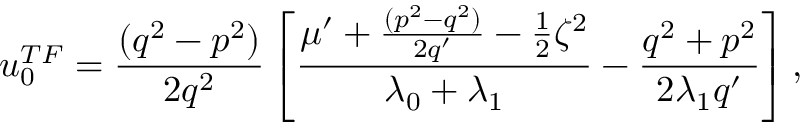Convert formula to latex. <formula><loc_0><loc_0><loc_500><loc_500>u _ { 0 } ^ { T F } = \frac { ( q ^ { 2 } - p ^ { 2 } ) } { 2 q ^ { 2 } } \left [ \frac { \mu ^ { \prime } + \frac { ( p ^ { 2 } - q ^ { 2 } ) } { 2 q ^ { \prime } } - \frac { 1 } { 2 } \zeta ^ { 2 } } { \lambda _ { 0 } + \lambda _ { 1 } } - \frac { q ^ { 2 } + p ^ { 2 } } { 2 \lambda _ { 1 } q ^ { \prime } } \right ] ,</formula> 